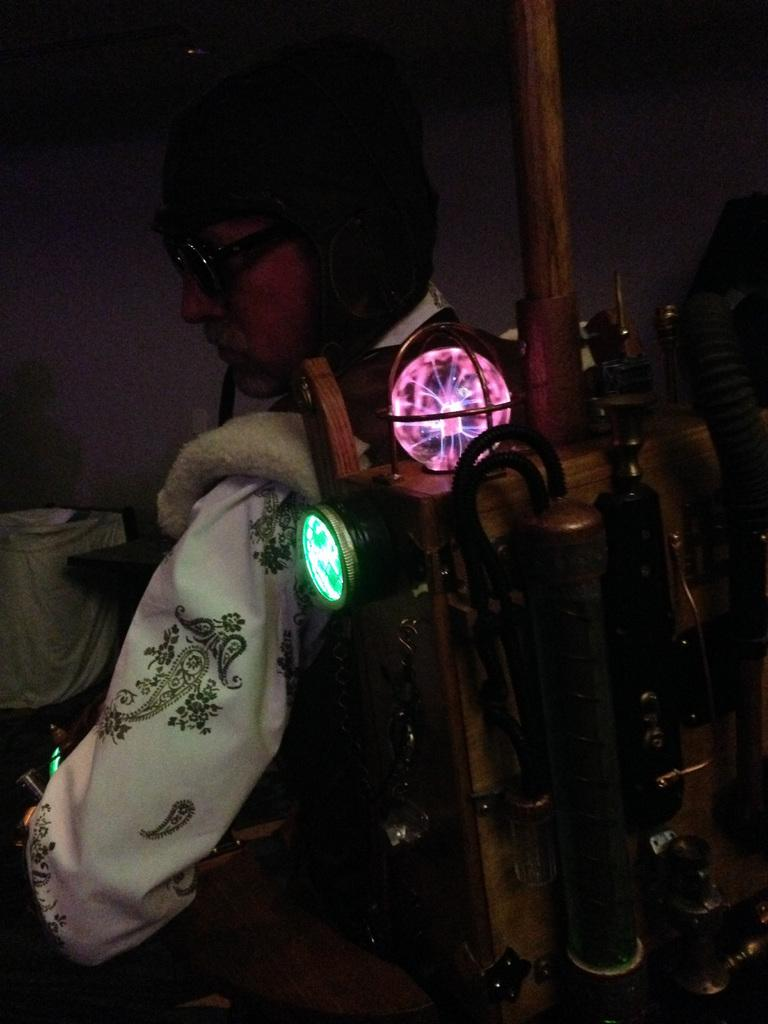What is the main subject of the image? There is a person in the image. What is the person wearing on their head? The person is wearing a helmet. What else is the person wearing that is visible in the image? The person is wearing an object with lights. What type of trail can be seen in the image? There is no trail visible in the image; it features a person wearing a helmet and an object with lights. 